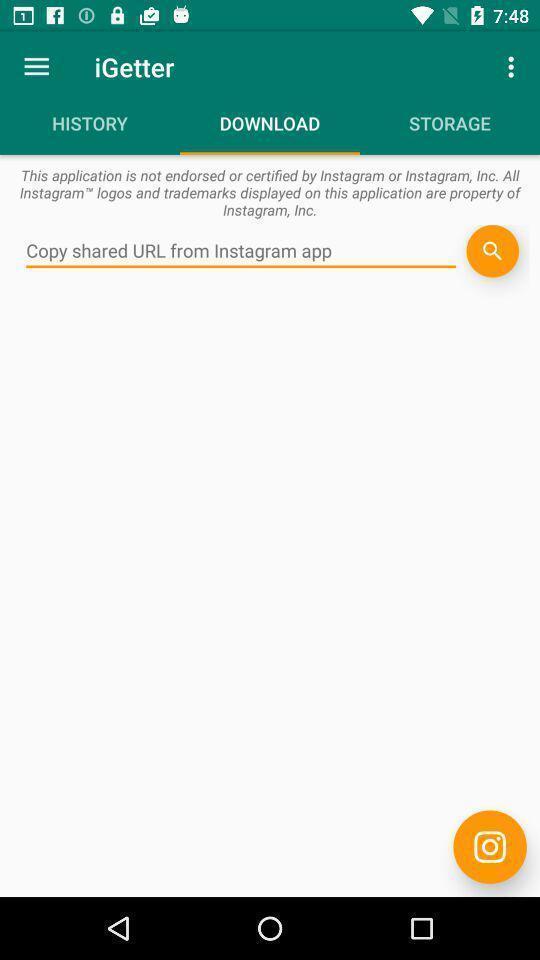Provide a textual representation of this image. Page showing list of downloads. 